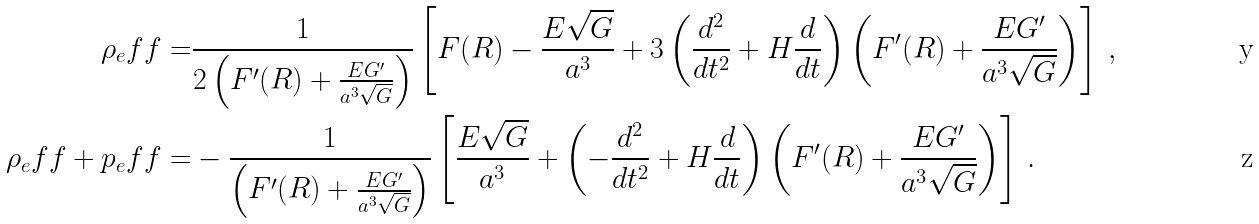<formula> <loc_0><loc_0><loc_500><loc_500>\rho _ { e } f f = & \frac { 1 } { 2 \left ( F ^ { \prime } ( R ) + \frac { E G ^ { \prime } } { a ^ { 3 } \sqrt { G } } \right ) } \left [ F ( R ) - \frac { E \sqrt { G } } { a ^ { 3 } } + 3 \left ( \frac { d ^ { 2 } } { d t ^ { 2 } } + H \frac { d } { d t } \right ) \left ( F ^ { \prime } ( R ) + \frac { E G ^ { \prime } } { a ^ { 3 } \sqrt { G } } \right ) \right ] \, , \\ \rho _ { e } f f + p _ { e } f f = & - \frac { 1 } { \left ( F ^ { \prime } ( R ) + \frac { E G ^ { \prime } } { a ^ { 3 } \sqrt { G } } \right ) } \left [ \frac { E \sqrt { G } } { a ^ { 3 } } + \left ( - \frac { d ^ { 2 } } { d t ^ { 2 } } + H \frac { d } { d t } \right ) \left ( F ^ { \prime } ( R ) + \frac { E G ^ { \prime } } { a ^ { 3 } \sqrt { G } } \right ) \right ] \, .</formula> 